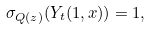<formula> <loc_0><loc_0><loc_500><loc_500>\sigma _ { Q ( z ) } ( Y _ { t } ( { 1 } , x ) ) = 1 ,</formula> 